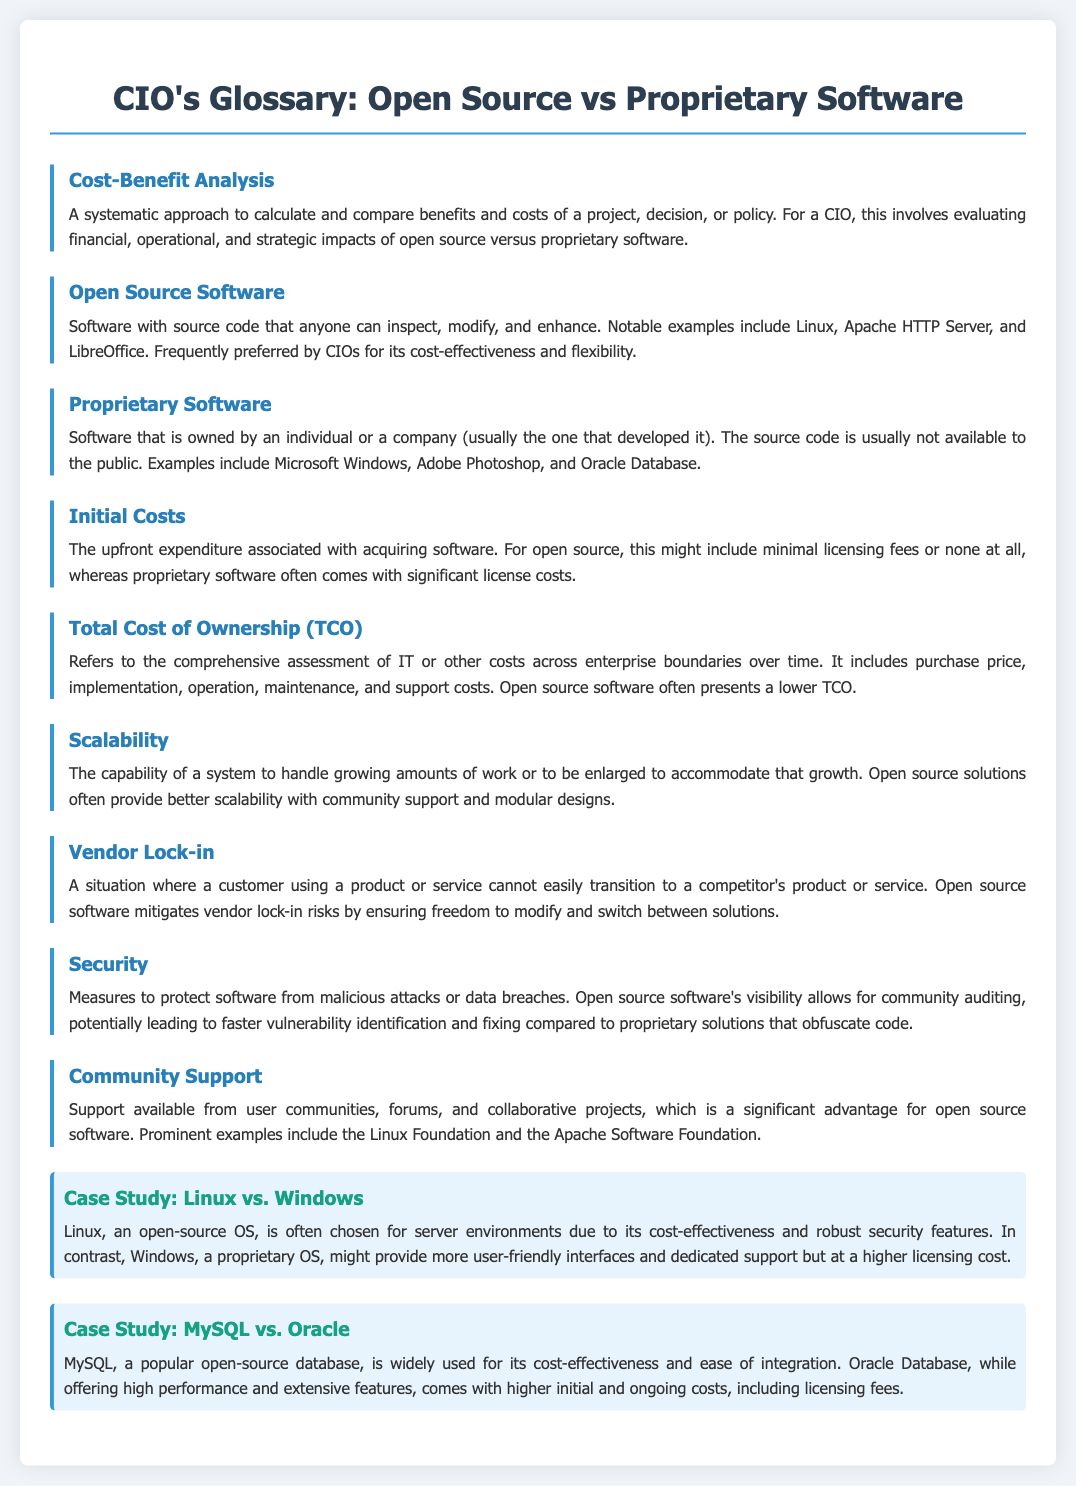What is Cost-Benefit Analysis? Cost-Benefit Analysis is defined as a systematic approach to calculate and compare benefits and costs of a project, decision, or policy.
Answer: A systematic approach to calculate and compare benefits and costs What does Open Source Software allow? Open Source Software is defined as software with source code that anyone can inspect, modify, and enhance.
Answer: Inspect, modify, and enhance What are Initial Costs associated with? Initial Costs refer to the upfront expenditure associated with acquiring software.
Answer: Upfront expenditure associated with acquiring software What does TCO stand for? TCO is defined in the document as Total Cost of Ownership.
Answer: Total Cost of Ownership Which software offers better scalability? The document states that open source solutions often provide better scalability.
Answer: Open source solutions Why is Vendor Lock-in relevant? Vendor Lock-in is a situation where a customer cannot easily transition to a competitor's product or service.
Answer: A situation of difficult transition to competitors In the case study, which operating system is cost-effective? The case study comparing Linux and Windows indicates that Linux is chosen for its cost-effectiveness.
Answer: Linux What does Community Support signify in open source? Community Support refers to support available from user communities and collaborative projects, which is an advantage for open source software.
Answer: Support from user communities and collaborative projects What is contrasted in the MySQL vs. Oracle case study? The case study contrasts MySQL, known for cost-effectiveness, with Oracle Database, which has higher costs.
Answer: Cost-effectiveness of MySQL vs. higher costs of Oracle Database 